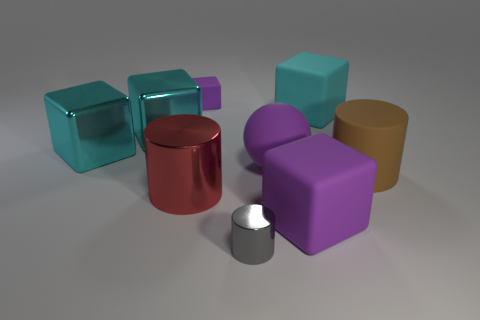Do the tiny matte block and the rubber cube in front of the big purple sphere have the same color?
Give a very brief answer. Yes. The rubber cylinder that is the same size as the purple sphere is what color?
Offer a very short reply. Brown. Are there any large purple rubber things that have the same shape as the cyan matte thing?
Ensure brevity in your answer.  Yes. Are there fewer large red metal things than large yellow shiny objects?
Offer a terse response. No. What is the color of the big cylinder that is right of the gray cylinder?
Your response must be concise. Brown. There is a small object behind the large brown matte cylinder that is on the right side of the purple rubber sphere; what shape is it?
Make the answer very short. Cube. Is the red cylinder made of the same material as the purple cube in front of the large red thing?
Make the answer very short. No. What is the shape of the small rubber object that is the same color as the large ball?
Offer a very short reply. Cube. How many other brown things have the same size as the brown thing?
Your answer should be compact. 0. Are there fewer metallic blocks in front of the brown matte cylinder than spheres?
Keep it short and to the point. Yes. 